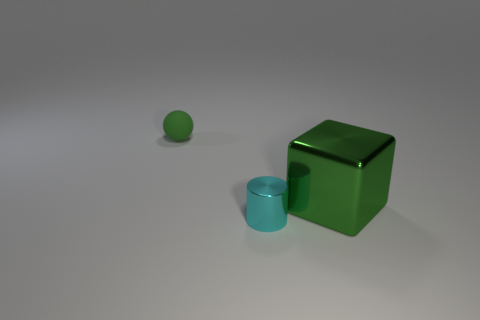Add 2 large green metal blocks. How many objects exist? 5 Subtract all cubes. How many objects are left? 2 Subtract all large metal blocks. Subtract all small cyan metal things. How many objects are left? 1 Add 2 cyan cylinders. How many cyan cylinders are left? 3 Add 3 tiny green rubber things. How many tiny green rubber things exist? 4 Subtract 0 cyan cubes. How many objects are left? 3 